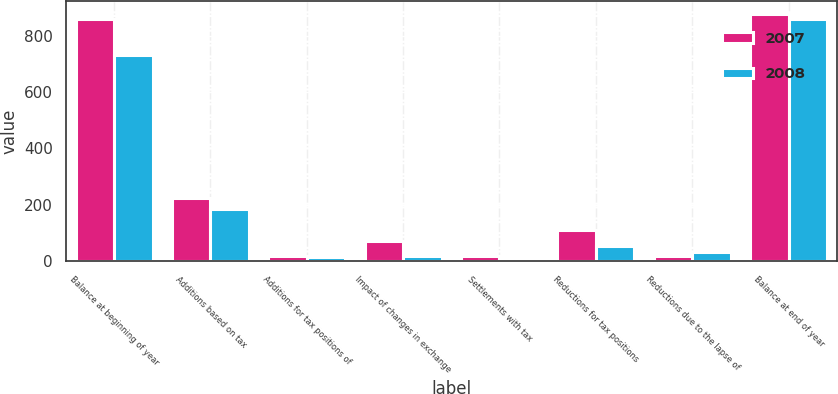<chart> <loc_0><loc_0><loc_500><loc_500><stacked_bar_chart><ecel><fcel>Balance at beginning of year<fcel>Additions based on tax<fcel>Additions for tax positions of<fcel>Impact of changes in exchange<fcel>Settlements with tax<fcel>Reductions for tax positions<fcel>Reductions due to the lapse of<fcel>Balance at end of year<nl><fcel>2007<fcel>858<fcel>223<fcel>19<fcel>72<fcel>20<fcel>111<fcel>20<fcel>877<nl><fcel>2008<fcel>730<fcel>187<fcel>16<fcel>21<fcel>8<fcel>55<fcel>33<fcel>858<nl></chart> 